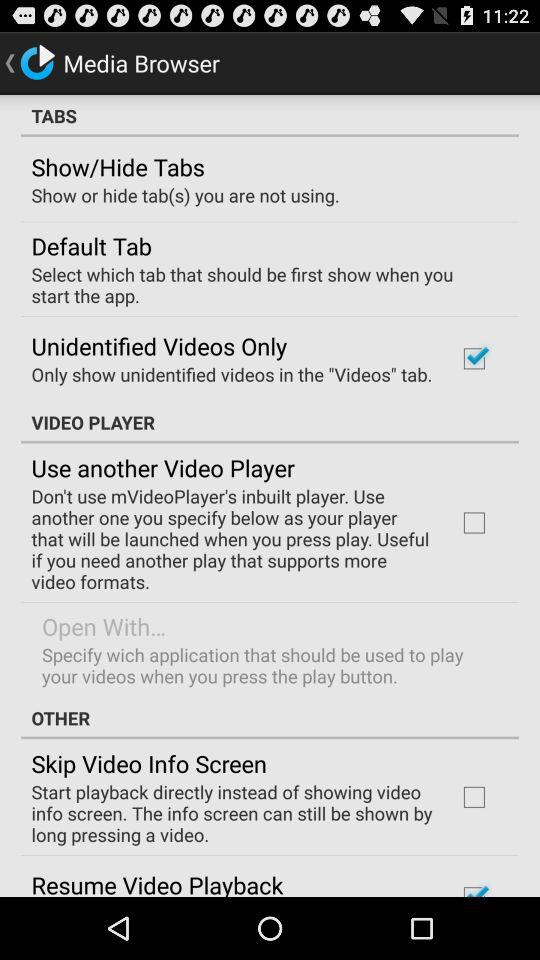What is the status of "Unidentified Videos Only"? The status is "on". 